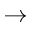<formula> <loc_0><loc_0><loc_500><loc_500>\rightarrow</formula> 